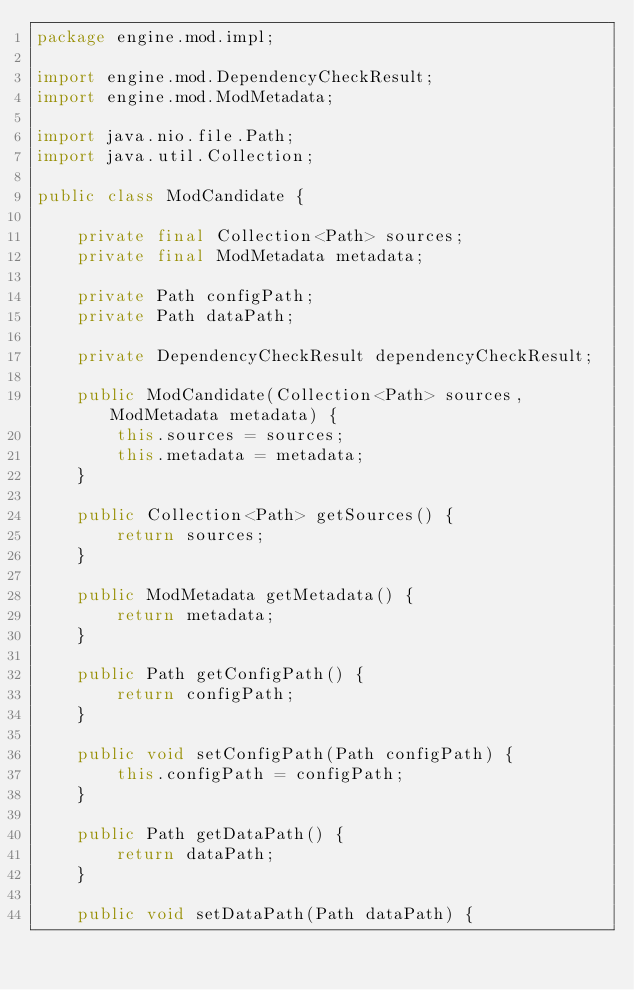<code> <loc_0><loc_0><loc_500><loc_500><_Java_>package engine.mod.impl;

import engine.mod.DependencyCheckResult;
import engine.mod.ModMetadata;

import java.nio.file.Path;
import java.util.Collection;

public class ModCandidate {

    private final Collection<Path> sources;
    private final ModMetadata metadata;

    private Path configPath;
    private Path dataPath;

    private DependencyCheckResult dependencyCheckResult;

    public ModCandidate(Collection<Path> sources, ModMetadata metadata) {
        this.sources = sources;
        this.metadata = metadata;
    }

    public Collection<Path> getSources() {
        return sources;
    }

    public ModMetadata getMetadata() {
        return metadata;
    }

    public Path getConfigPath() {
        return configPath;
    }

    public void setConfigPath(Path configPath) {
        this.configPath = configPath;
    }

    public Path getDataPath() {
        return dataPath;
    }

    public void setDataPath(Path dataPath) {</code> 